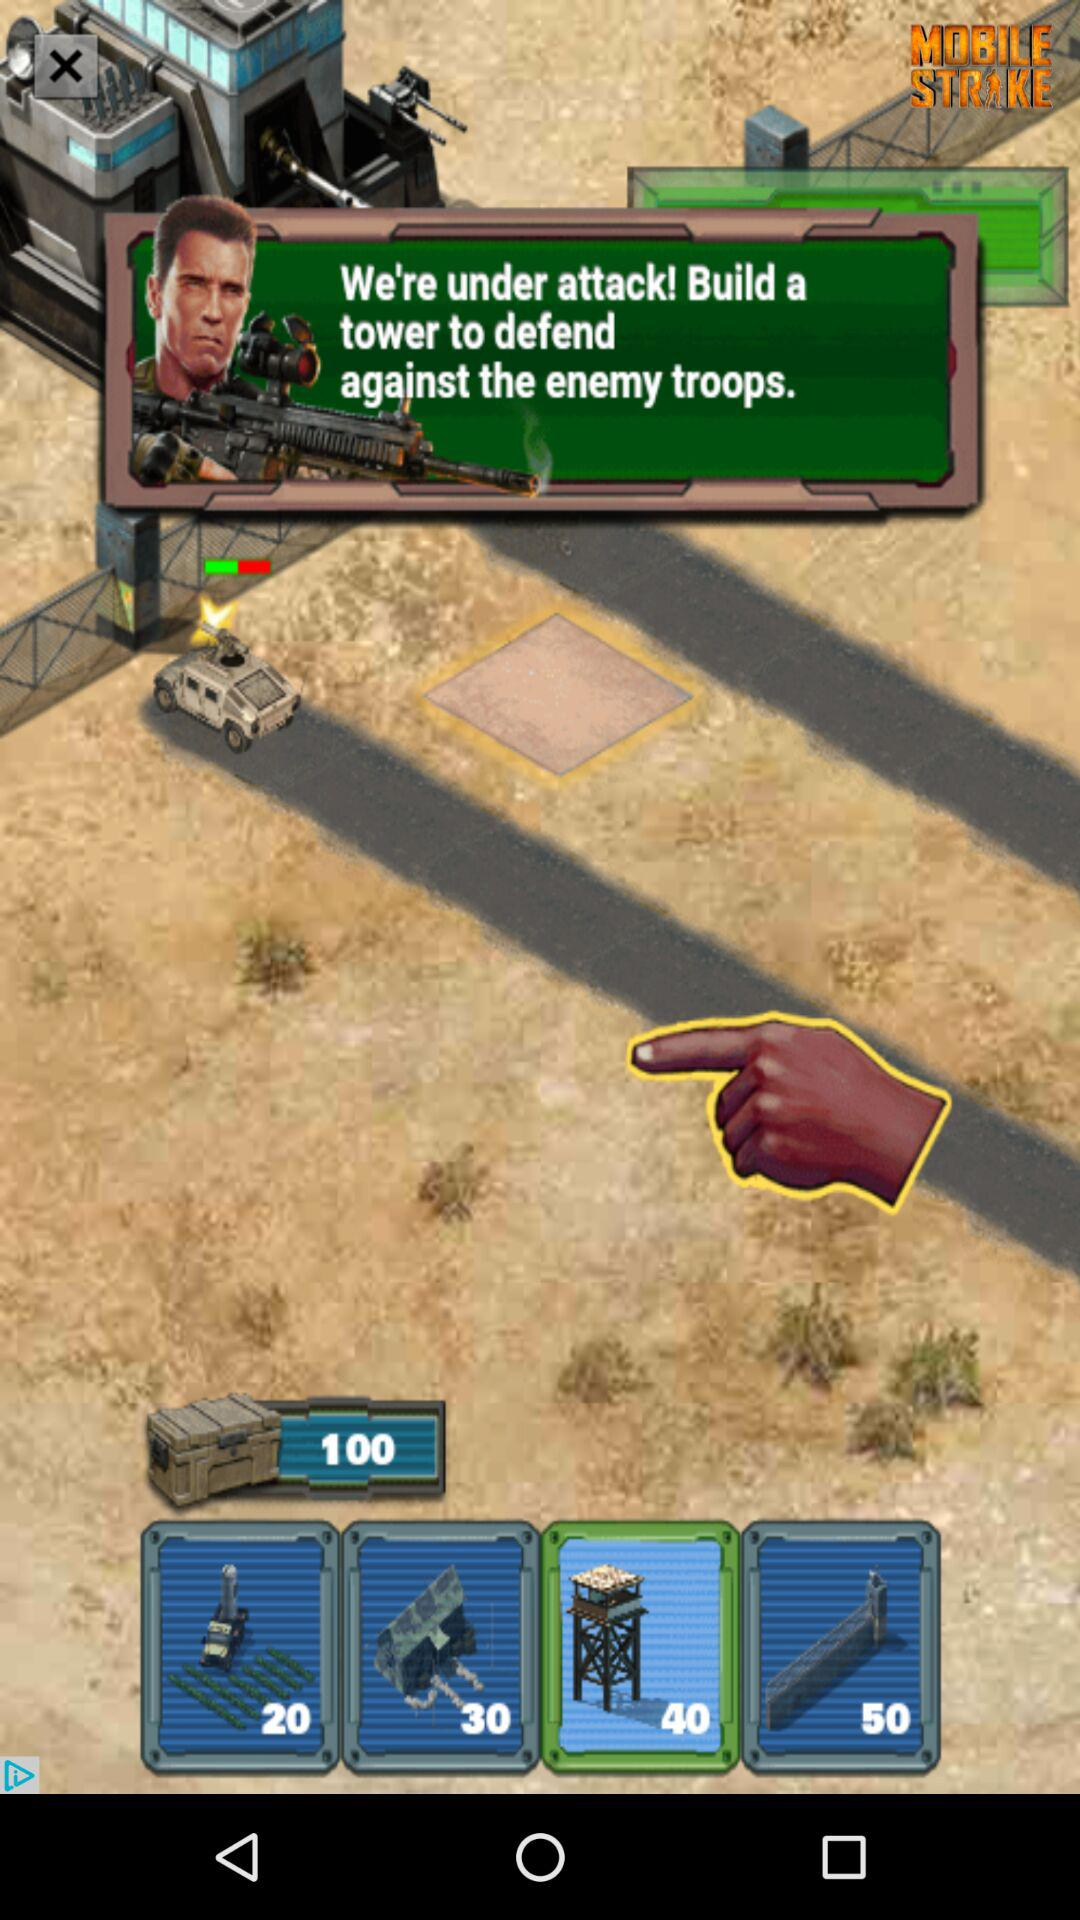What is the score?
When the provided information is insufficient, respond with <no answer>. <no answer> 